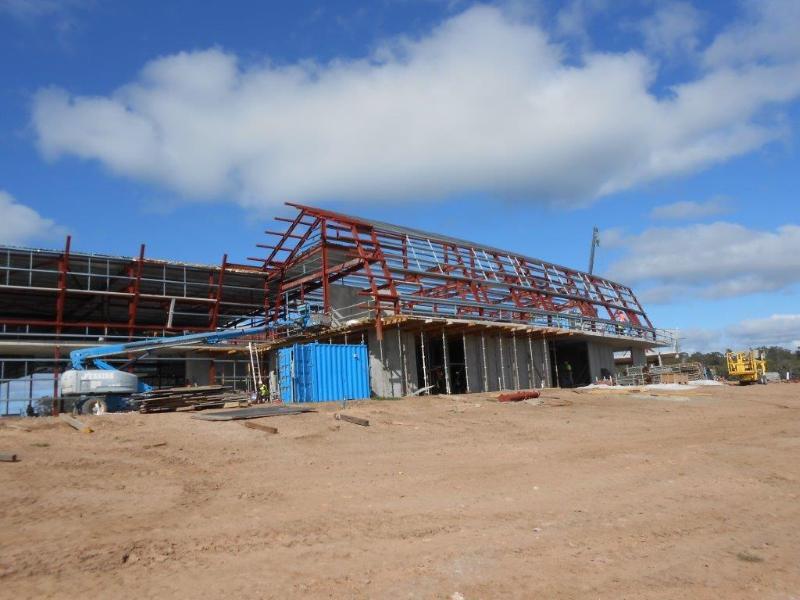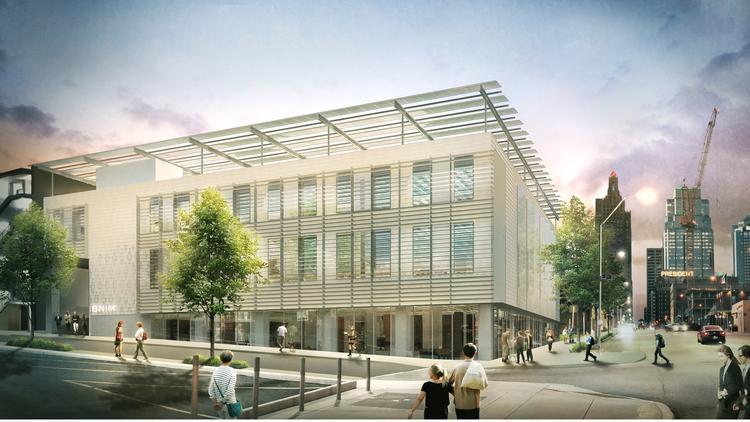The first image is the image on the left, the second image is the image on the right. Assess this claim about the two images: "In one image there are at least two cranes.". Correct or not? Answer yes or no. No. 